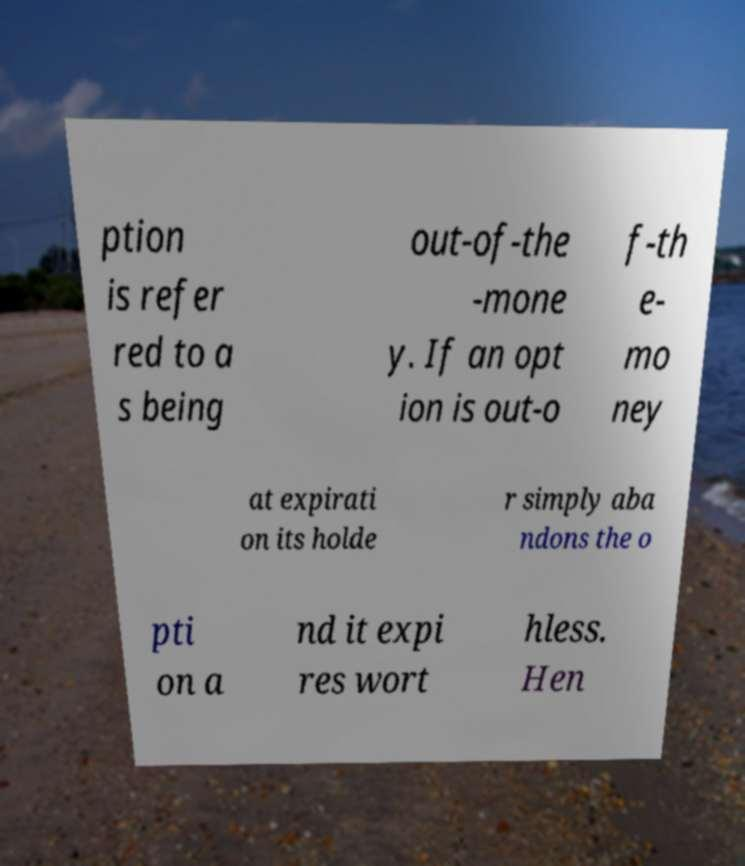For documentation purposes, I need the text within this image transcribed. Could you provide that? ption is refer red to a s being out-of-the -mone y. If an opt ion is out-o f-th e- mo ney at expirati on its holde r simply aba ndons the o pti on a nd it expi res wort hless. Hen 